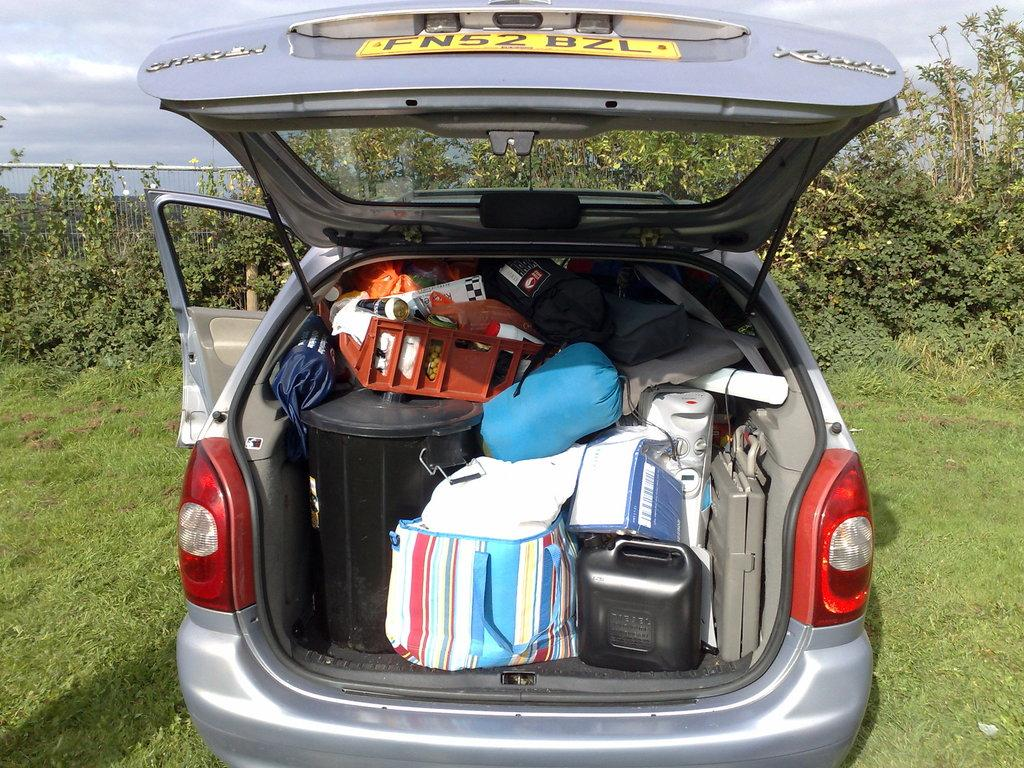What is inside the car in the image? There are bags inside a car in the image. How are the bags positioned in the car? The bags are stuffed tightly. What can be seen in the background of the image? There are plants on the grassland in the back of the image. What is visible in the sky in the image? The sky is visible in the image, and clouds are present. What flavor of ice cream is being discussed at the meeting in the image? There is no meeting or ice cream present in the image. What is the phase of the moon visible in the image? The image does not show the moon; it only shows the sky with clouds. 